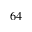Convert formula to latex. <formula><loc_0><loc_0><loc_500><loc_500>6 4</formula> 